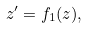<formula> <loc_0><loc_0><loc_500><loc_500>z ^ { \prime } = f _ { 1 } ( z ) ,</formula> 